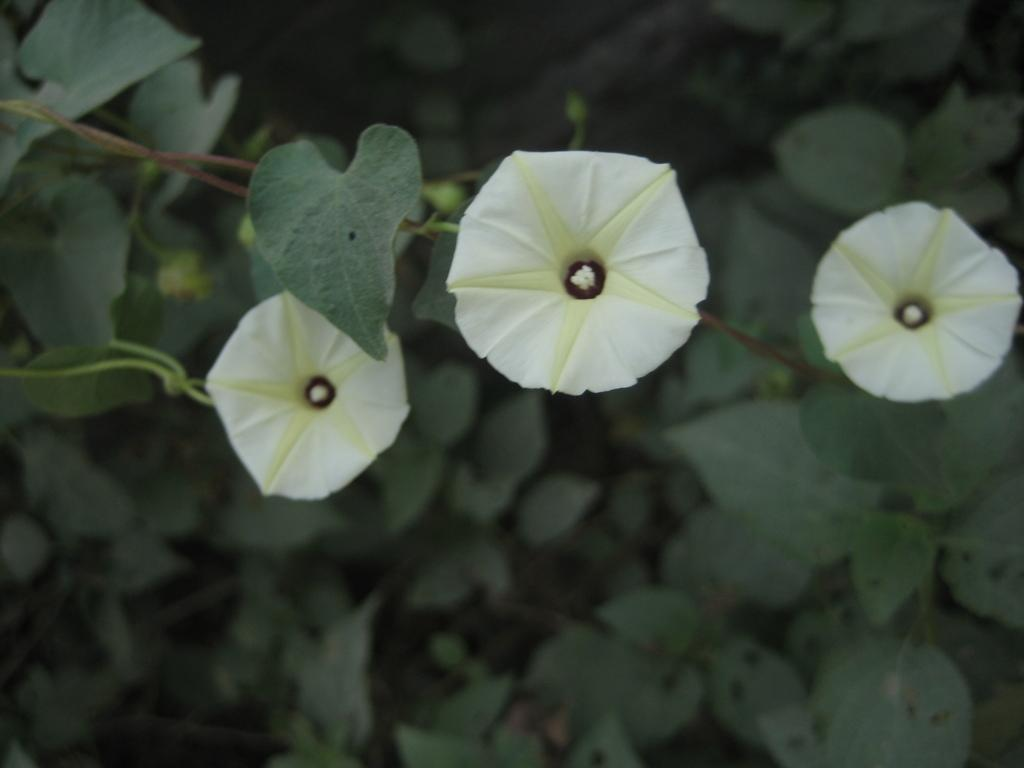What type of living organisms are in the image? There is a group of plants in the image. What additional features can be seen with the plants in the image? There are flowers associated with the plants in the image. Where can the clam be seen in the image? There is no clam present in the image. What type of animal is the dog in the image? There is no dog present in the image. Can you tell me where the market is located in the image? There is no market present in the image. 